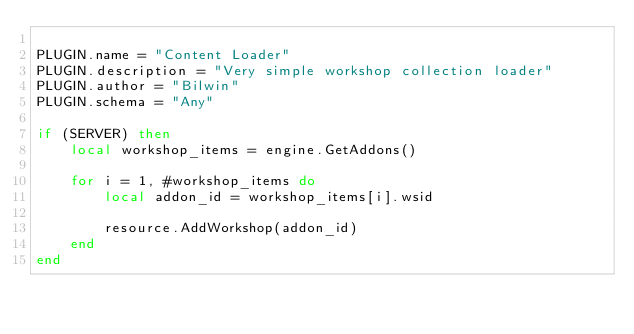Convert code to text. <code><loc_0><loc_0><loc_500><loc_500><_Lua_>
PLUGIN.name = "Content Loader"
PLUGIN.description = "Very simple workshop collection loader"
PLUGIN.author = "Bilwin"
PLUGIN.schema = "Any"

if (SERVER) then
    local workshop_items = engine.GetAddons()

    for i = 1, #workshop_items do
        local addon_id = workshop_items[i].wsid

        resource.AddWorkshop(addon_id)
    end
end</code> 